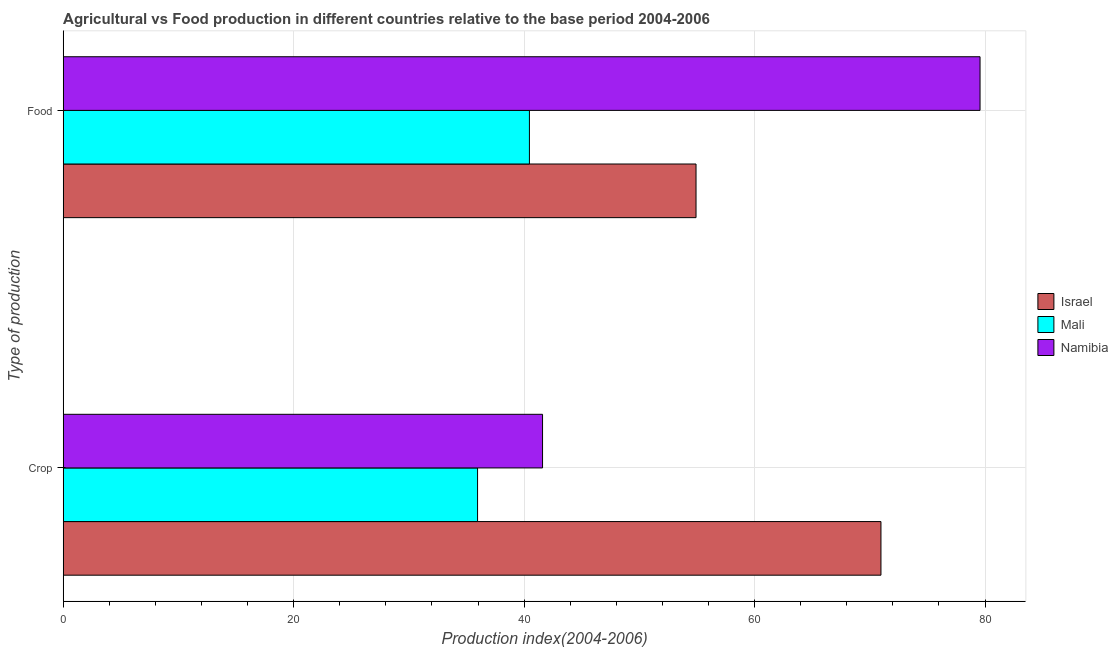How many different coloured bars are there?
Offer a very short reply. 3. How many groups of bars are there?
Offer a very short reply. 2. How many bars are there on the 1st tick from the top?
Keep it short and to the point. 3. What is the label of the 2nd group of bars from the top?
Your answer should be very brief. Crop. What is the crop production index in Israel?
Offer a very short reply. 70.97. Across all countries, what is the maximum crop production index?
Your response must be concise. 70.97. Across all countries, what is the minimum food production index?
Your response must be concise. 40.46. In which country was the food production index maximum?
Offer a terse response. Namibia. In which country was the crop production index minimum?
Provide a short and direct response. Mali. What is the total food production index in the graph?
Give a very brief answer. 174.95. What is the difference between the crop production index in Israel and that in Mali?
Provide a succinct answer. 35.01. What is the difference between the crop production index in Namibia and the food production index in Israel?
Make the answer very short. -13.32. What is the average food production index per country?
Give a very brief answer. 58.32. What is the ratio of the food production index in Israel to that in Namibia?
Give a very brief answer. 0.69. Is the food production index in Namibia less than that in Israel?
Offer a very short reply. No. In how many countries, is the crop production index greater than the average crop production index taken over all countries?
Make the answer very short. 1. What does the 2nd bar from the top in Food represents?
Ensure brevity in your answer.  Mali. What does the 2nd bar from the bottom in Crop represents?
Your answer should be very brief. Mali. Are all the bars in the graph horizontal?
Your answer should be very brief. Yes. What is the difference between two consecutive major ticks on the X-axis?
Your response must be concise. 20. Does the graph contain grids?
Offer a very short reply. Yes. Where does the legend appear in the graph?
Offer a terse response. Center right. What is the title of the graph?
Offer a terse response. Agricultural vs Food production in different countries relative to the base period 2004-2006. What is the label or title of the X-axis?
Your answer should be very brief. Production index(2004-2006). What is the label or title of the Y-axis?
Provide a short and direct response. Type of production. What is the Production index(2004-2006) in Israel in Crop?
Your answer should be compact. 70.97. What is the Production index(2004-2006) of Mali in Crop?
Provide a short and direct response. 35.96. What is the Production index(2004-2006) in Namibia in Crop?
Give a very brief answer. 41.6. What is the Production index(2004-2006) in Israel in Food?
Your response must be concise. 54.92. What is the Production index(2004-2006) of Mali in Food?
Your answer should be very brief. 40.46. What is the Production index(2004-2006) of Namibia in Food?
Give a very brief answer. 79.57. Across all Type of production, what is the maximum Production index(2004-2006) of Israel?
Give a very brief answer. 70.97. Across all Type of production, what is the maximum Production index(2004-2006) in Mali?
Your answer should be very brief. 40.46. Across all Type of production, what is the maximum Production index(2004-2006) of Namibia?
Offer a very short reply. 79.57. Across all Type of production, what is the minimum Production index(2004-2006) of Israel?
Your answer should be very brief. 54.92. Across all Type of production, what is the minimum Production index(2004-2006) in Mali?
Offer a very short reply. 35.96. Across all Type of production, what is the minimum Production index(2004-2006) of Namibia?
Your answer should be very brief. 41.6. What is the total Production index(2004-2006) in Israel in the graph?
Offer a terse response. 125.89. What is the total Production index(2004-2006) of Mali in the graph?
Make the answer very short. 76.42. What is the total Production index(2004-2006) in Namibia in the graph?
Give a very brief answer. 121.17. What is the difference between the Production index(2004-2006) in Israel in Crop and that in Food?
Offer a very short reply. 16.05. What is the difference between the Production index(2004-2006) in Mali in Crop and that in Food?
Offer a terse response. -4.5. What is the difference between the Production index(2004-2006) of Namibia in Crop and that in Food?
Give a very brief answer. -37.97. What is the difference between the Production index(2004-2006) of Israel in Crop and the Production index(2004-2006) of Mali in Food?
Give a very brief answer. 30.51. What is the difference between the Production index(2004-2006) in Mali in Crop and the Production index(2004-2006) in Namibia in Food?
Keep it short and to the point. -43.61. What is the average Production index(2004-2006) in Israel per Type of production?
Offer a very short reply. 62.95. What is the average Production index(2004-2006) of Mali per Type of production?
Your response must be concise. 38.21. What is the average Production index(2004-2006) of Namibia per Type of production?
Offer a terse response. 60.59. What is the difference between the Production index(2004-2006) of Israel and Production index(2004-2006) of Mali in Crop?
Keep it short and to the point. 35.01. What is the difference between the Production index(2004-2006) in Israel and Production index(2004-2006) in Namibia in Crop?
Your response must be concise. 29.37. What is the difference between the Production index(2004-2006) of Mali and Production index(2004-2006) of Namibia in Crop?
Keep it short and to the point. -5.64. What is the difference between the Production index(2004-2006) in Israel and Production index(2004-2006) in Mali in Food?
Offer a terse response. 14.46. What is the difference between the Production index(2004-2006) in Israel and Production index(2004-2006) in Namibia in Food?
Provide a short and direct response. -24.65. What is the difference between the Production index(2004-2006) of Mali and Production index(2004-2006) of Namibia in Food?
Offer a terse response. -39.11. What is the ratio of the Production index(2004-2006) in Israel in Crop to that in Food?
Offer a terse response. 1.29. What is the ratio of the Production index(2004-2006) in Mali in Crop to that in Food?
Your response must be concise. 0.89. What is the ratio of the Production index(2004-2006) of Namibia in Crop to that in Food?
Offer a very short reply. 0.52. What is the difference between the highest and the second highest Production index(2004-2006) in Israel?
Keep it short and to the point. 16.05. What is the difference between the highest and the second highest Production index(2004-2006) in Mali?
Keep it short and to the point. 4.5. What is the difference between the highest and the second highest Production index(2004-2006) in Namibia?
Give a very brief answer. 37.97. What is the difference between the highest and the lowest Production index(2004-2006) in Israel?
Keep it short and to the point. 16.05. What is the difference between the highest and the lowest Production index(2004-2006) of Namibia?
Provide a succinct answer. 37.97. 